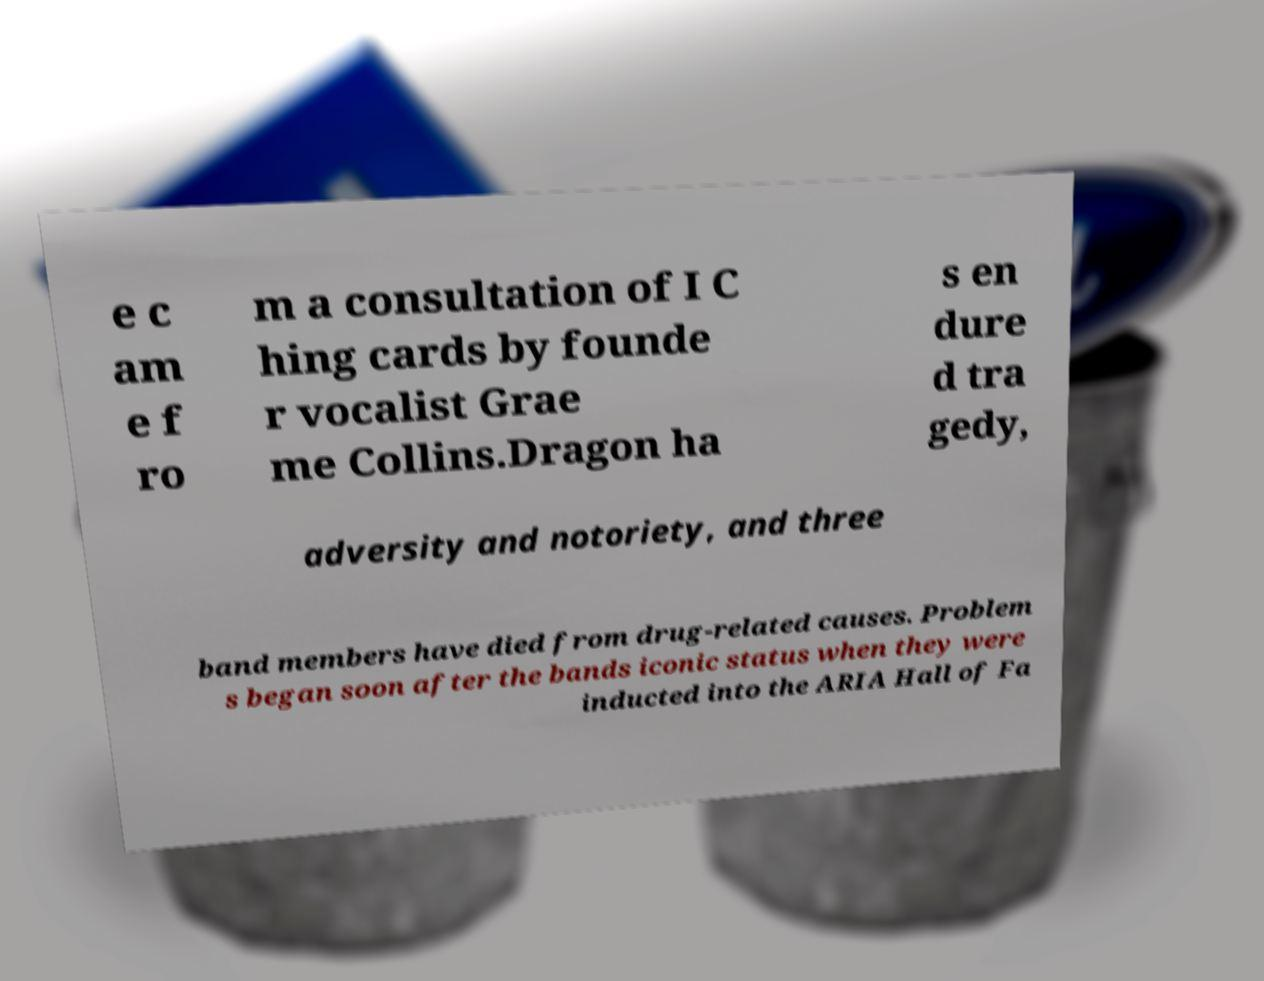I need the written content from this picture converted into text. Can you do that? e c am e f ro m a consultation of I C hing cards by founde r vocalist Grae me Collins.Dragon ha s en dure d tra gedy, adversity and notoriety, and three band members have died from drug-related causes. Problem s began soon after the bands iconic status when they were inducted into the ARIA Hall of Fa 